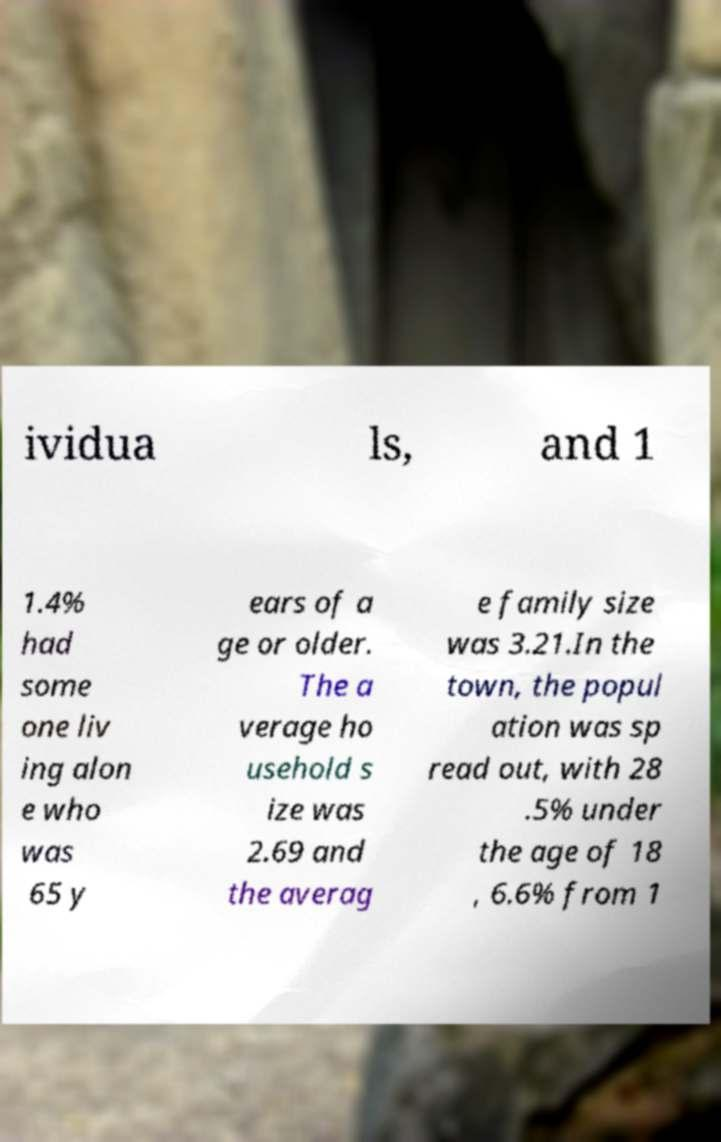Can you accurately transcribe the text from the provided image for me? ividua ls, and 1 1.4% had some one liv ing alon e who was 65 y ears of a ge or older. The a verage ho usehold s ize was 2.69 and the averag e family size was 3.21.In the town, the popul ation was sp read out, with 28 .5% under the age of 18 , 6.6% from 1 